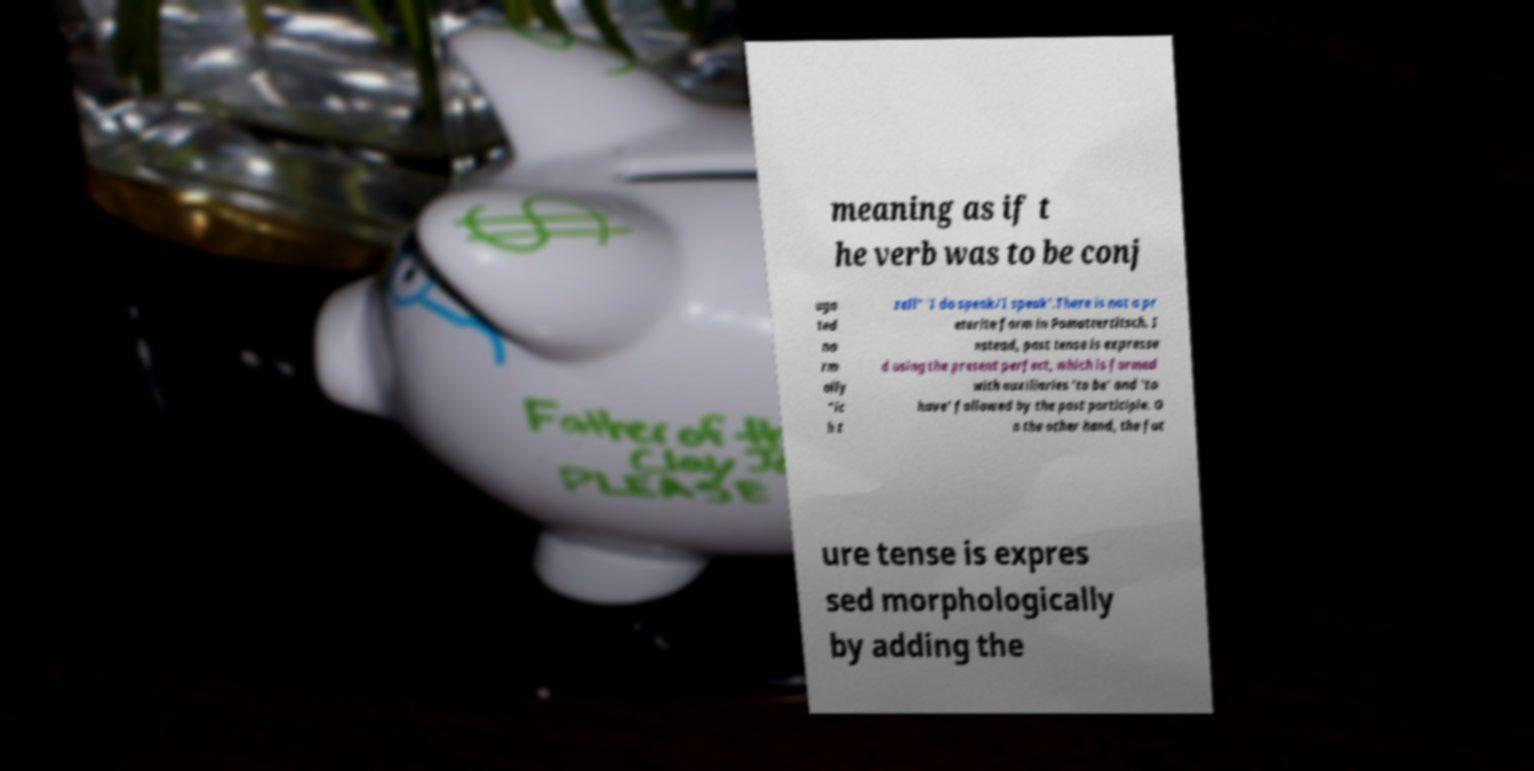What messages or text are displayed in this image? I need them in a readable, typed format. meaning as if t he verb was to be conj uga ted no rm ally "ic h t zell" 'I do speak/I speak'.There is not a pr eterite form in Pomattertitsch. I nstead, past tense is expresse d using the present perfect, which is formed with auxiliaries 'to be' and 'to have' followed by the past participle. O n the other hand, the fut ure tense is expres sed morphologically by adding the 